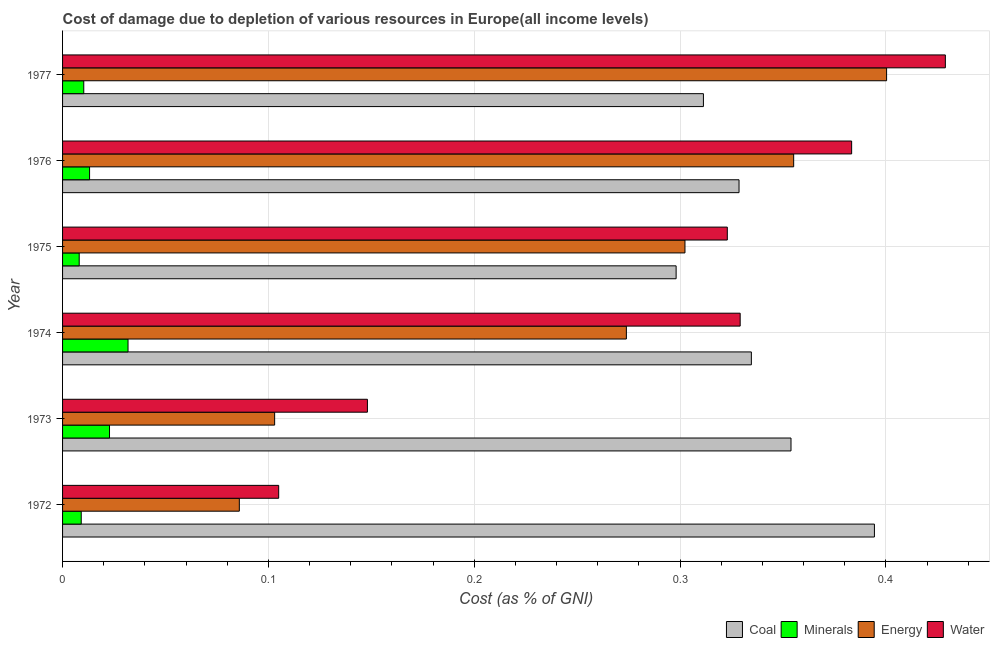How many different coloured bars are there?
Keep it short and to the point. 4. Are the number of bars per tick equal to the number of legend labels?
Provide a succinct answer. Yes. How many bars are there on the 2nd tick from the top?
Provide a succinct answer. 4. What is the label of the 3rd group of bars from the top?
Make the answer very short. 1975. In how many cases, is the number of bars for a given year not equal to the number of legend labels?
Make the answer very short. 0. What is the cost of damage due to depletion of energy in 1977?
Your response must be concise. 0.4. Across all years, what is the maximum cost of damage due to depletion of minerals?
Offer a very short reply. 0.03. Across all years, what is the minimum cost of damage due to depletion of minerals?
Offer a terse response. 0.01. In which year was the cost of damage due to depletion of coal minimum?
Offer a terse response. 1975. What is the total cost of damage due to depletion of coal in the graph?
Ensure brevity in your answer.  2.02. What is the difference between the cost of damage due to depletion of minerals in 1972 and that in 1973?
Provide a succinct answer. -0.01. What is the difference between the cost of damage due to depletion of water in 1972 and the cost of damage due to depletion of minerals in 1974?
Offer a very short reply. 0.07. What is the average cost of damage due to depletion of minerals per year?
Provide a short and direct response. 0.02. In the year 1976, what is the difference between the cost of damage due to depletion of coal and cost of damage due to depletion of water?
Make the answer very short. -0.06. What is the ratio of the cost of damage due to depletion of energy in 1972 to that in 1976?
Provide a short and direct response. 0.24. Is the cost of damage due to depletion of water in 1974 less than that in 1976?
Offer a terse response. Yes. Is the difference between the cost of damage due to depletion of coal in 1975 and 1976 greater than the difference between the cost of damage due to depletion of water in 1975 and 1976?
Provide a short and direct response. Yes. What is the difference between the highest and the second highest cost of damage due to depletion of water?
Give a very brief answer. 0.05. What is the difference between the highest and the lowest cost of damage due to depletion of coal?
Your response must be concise. 0.1. Is it the case that in every year, the sum of the cost of damage due to depletion of coal and cost of damage due to depletion of minerals is greater than the sum of cost of damage due to depletion of water and cost of damage due to depletion of energy?
Ensure brevity in your answer.  No. What does the 2nd bar from the top in 1972 represents?
Offer a terse response. Energy. What does the 4th bar from the bottom in 1975 represents?
Your response must be concise. Water. Are all the bars in the graph horizontal?
Give a very brief answer. Yes. Does the graph contain grids?
Give a very brief answer. Yes. How many legend labels are there?
Your answer should be very brief. 4. What is the title of the graph?
Your answer should be compact. Cost of damage due to depletion of various resources in Europe(all income levels) . What is the label or title of the X-axis?
Give a very brief answer. Cost (as % of GNI). What is the Cost (as % of GNI) in Coal in 1972?
Ensure brevity in your answer.  0.39. What is the Cost (as % of GNI) of Minerals in 1972?
Keep it short and to the point. 0.01. What is the Cost (as % of GNI) of Energy in 1972?
Ensure brevity in your answer.  0.09. What is the Cost (as % of GNI) of Water in 1972?
Give a very brief answer. 0.1. What is the Cost (as % of GNI) in Coal in 1973?
Your answer should be very brief. 0.35. What is the Cost (as % of GNI) in Minerals in 1973?
Give a very brief answer. 0.02. What is the Cost (as % of GNI) of Energy in 1973?
Your answer should be compact. 0.1. What is the Cost (as % of GNI) in Water in 1973?
Make the answer very short. 0.15. What is the Cost (as % of GNI) in Coal in 1974?
Make the answer very short. 0.33. What is the Cost (as % of GNI) of Minerals in 1974?
Provide a succinct answer. 0.03. What is the Cost (as % of GNI) of Energy in 1974?
Offer a very short reply. 0.27. What is the Cost (as % of GNI) of Water in 1974?
Keep it short and to the point. 0.33. What is the Cost (as % of GNI) of Coal in 1975?
Provide a short and direct response. 0.3. What is the Cost (as % of GNI) in Minerals in 1975?
Offer a terse response. 0.01. What is the Cost (as % of GNI) in Energy in 1975?
Give a very brief answer. 0.3. What is the Cost (as % of GNI) of Water in 1975?
Offer a terse response. 0.32. What is the Cost (as % of GNI) in Coal in 1976?
Make the answer very short. 0.33. What is the Cost (as % of GNI) of Minerals in 1976?
Provide a short and direct response. 0.01. What is the Cost (as % of GNI) of Energy in 1976?
Provide a short and direct response. 0.36. What is the Cost (as % of GNI) of Water in 1976?
Offer a very short reply. 0.38. What is the Cost (as % of GNI) in Coal in 1977?
Offer a very short reply. 0.31. What is the Cost (as % of GNI) of Minerals in 1977?
Offer a very short reply. 0.01. What is the Cost (as % of GNI) of Energy in 1977?
Provide a succinct answer. 0.4. What is the Cost (as % of GNI) of Water in 1977?
Make the answer very short. 0.43. Across all years, what is the maximum Cost (as % of GNI) of Coal?
Your answer should be very brief. 0.39. Across all years, what is the maximum Cost (as % of GNI) in Minerals?
Your answer should be compact. 0.03. Across all years, what is the maximum Cost (as % of GNI) in Energy?
Give a very brief answer. 0.4. Across all years, what is the maximum Cost (as % of GNI) of Water?
Offer a very short reply. 0.43. Across all years, what is the minimum Cost (as % of GNI) of Coal?
Ensure brevity in your answer.  0.3. Across all years, what is the minimum Cost (as % of GNI) in Minerals?
Keep it short and to the point. 0.01. Across all years, what is the minimum Cost (as % of GNI) in Energy?
Ensure brevity in your answer.  0.09. Across all years, what is the minimum Cost (as % of GNI) in Water?
Offer a very short reply. 0.1. What is the total Cost (as % of GNI) in Coal in the graph?
Your answer should be very brief. 2.02. What is the total Cost (as % of GNI) of Minerals in the graph?
Give a very brief answer. 0.1. What is the total Cost (as % of GNI) of Energy in the graph?
Keep it short and to the point. 1.52. What is the total Cost (as % of GNI) in Water in the graph?
Offer a very short reply. 1.72. What is the difference between the Cost (as % of GNI) in Coal in 1972 and that in 1973?
Make the answer very short. 0.04. What is the difference between the Cost (as % of GNI) in Minerals in 1972 and that in 1973?
Provide a succinct answer. -0.01. What is the difference between the Cost (as % of GNI) of Energy in 1972 and that in 1973?
Your response must be concise. -0.02. What is the difference between the Cost (as % of GNI) in Water in 1972 and that in 1973?
Provide a short and direct response. -0.04. What is the difference between the Cost (as % of GNI) of Coal in 1972 and that in 1974?
Your response must be concise. 0.06. What is the difference between the Cost (as % of GNI) in Minerals in 1972 and that in 1974?
Give a very brief answer. -0.02. What is the difference between the Cost (as % of GNI) in Energy in 1972 and that in 1974?
Offer a very short reply. -0.19. What is the difference between the Cost (as % of GNI) in Water in 1972 and that in 1974?
Keep it short and to the point. -0.22. What is the difference between the Cost (as % of GNI) in Coal in 1972 and that in 1975?
Provide a short and direct response. 0.1. What is the difference between the Cost (as % of GNI) in Minerals in 1972 and that in 1975?
Give a very brief answer. 0. What is the difference between the Cost (as % of GNI) of Energy in 1972 and that in 1975?
Give a very brief answer. -0.22. What is the difference between the Cost (as % of GNI) of Water in 1972 and that in 1975?
Your response must be concise. -0.22. What is the difference between the Cost (as % of GNI) of Coal in 1972 and that in 1976?
Make the answer very short. 0.07. What is the difference between the Cost (as % of GNI) in Minerals in 1972 and that in 1976?
Your answer should be very brief. -0. What is the difference between the Cost (as % of GNI) of Energy in 1972 and that in 1976?
Provide a short and direct response. -0.27. What is the difference between the Cost (as % of GNI) of Water in 1972 and that in 1976?
Your answer should be compact. -0.28. What is the difference between the Cost (as % of GNI) of Coal in 1972 and that in 1977?
Your response must be concise. 0.08. What is the difference between the Cost (as % of GNI) in Minerals in 1972 and that in 1977?
Offer a terse response. -0. What is the difference between the Cost (as % of GNI) in Energy in 1972 and that in 1977?
Keep it short and to the point. -0.31. What is the difference between the Cost (as % of GNI) in Water in 1972 and that in 1977?
Make the answer very short. -0.32. What is the difference between the Cost (as % of GNI) in Coal in 1973 and that in 1974?
Make the answer very short. 0.02. What is the difference between the Cost (as % of GNI) in Minerals in 1973 and that in 1974?
Offer a terse response. -0.01. What is the difference between the Cost (as % of GNI) of Energy in 1973 and that in 1974?
Keep it short and to the point. -0.17. What is the difference between the Cost (as % of GNI) of Water in 1973 and that in 1974?
Provide a short and direct response. -0.18. What is the difference between the Cost (as % of GNI) of Coal in 1973 and that in 1975?
Ensure brevity in your answer.  0.06. What is the difference between the Cost (as % of GNI) of Minerals in 1973 and that in 1975?
Your answer should be very brief. 0.01. What is the difference between the Cost (as % of GNI) of Energy in 1973 and that in 1975?
Your response must be concise. -0.2. What is the difference between the Cost (as % of GNI) in Water in 1973 and that in 1975?
Offer a terse response. -0.17. What is the difference between the Cost (as % of GNI) in Coal in 1973 and that in 1976?
Make the answer very short. 0.03. What is the difference between the Cost (as % of GNI) of Minerals in 1973 and that in 1976?
Offer a very short reply. 0.01. What is the difference between the Cost (as % of GNI) of Energy in 1973 and that in 1976?
Make the answer very short. -0.25. What is the difference between the Cost (as % of GNI) of Water in 1973 and that in 1976?
Ensure brevity in your answer.  -0.24. What is the difference between the Cost (as % of GNI) in Coal in 1973 and that in 1977?
Your response must be concise. 0.04. What is the difference between the Cost (as % of GNI) of Minerals in 1973 and that in 1977?
Your answer should be compact. 0.01. What is the difference between the Cost (as % of GNI) in Energy in 1973 and that in 1977?
Your answer should be compact. -0.3. What is the difference between the Cost (as % of GNI) of Water in 1973 and that in 1977?
Keep it short and to the point. -0.28. What is the difference between the Cost (as % of GNI) of Coal in 1974 and that in 1975?
Provide a short and direct response. 0.04. What is the difference between the Cost (as % of GNI) of Minerals in 1974 and that in 1975?
Give a very brief answer. 0.02. What is the difference between the Cost (as % of GNI) of Energy in 1974 and that in 1975?
Your answer should be compact. -0.03. What is the difference between the Cost (as % of GNI) of Water in 1974 and that in 1975?
Make the answer very short. 0.01. What is the difference between the Cost (as % of GNI) in Coal in 1974 and that in 1976?
Provide a short and direct response. 0.01. What is the difference between the Cost (as % of GNI) in Minerals in 1974 and that in 1976?
Offer a terse response. 0.02. What is the difference between the Cost (as % of GNI) in Energy in 1974 and that in 1976?
Your answer should be very brief. -0.08. What is the difference between the Cost (as % of GNI) of Water in 1974 and that in 1976?
Keep it short and to the point. -0.05. What is the difference between the Cost (as % of GNI) of Coal in 1974 and that in 1977?
Make the answer very short. 0.02. What is the difference between the Cost (as % of GNI) in Minerals in 1974 and that in 1977?
Your response must be concise. 0.02. What is the difference between the Cost (as % of GNI) in Energy in 1974 and that in 1977?
Provide a short and direct response. -0.13. What is the difference between the Cost (as % of GNI) in Water in 1974 and that in 1977?
Provide a short and direct response. -0.1. What is the difference between the Cost (as % of GNI) of Coal in 1975 and that in 1976?
Give a very brief answer. -0.03. What is the difference between the Cost (as % of GNI) in Minerals in 1975 and that in 1976?
Keep it short and to the point. -0.01. What is the difference between the Cost (as % of GNI) in Energy in 1975 and that in 1976?
Give a very brief answer. -0.05. What is the difference between the Cost (as % of GNI) of Water in 1975 and that in 1976?
Ensure brevity in your answer.  -0.06. What is the difference between the Cost (as % of GNI) in Coal in 1975 and that in 1977?
Ensure brevity in your answer.  -0.01. What is the difference between the Cost (as % of GNI) in Minerals in 1975 and that in 1977?
Make the answer very short. -0. What is the difference between the Cost (as % of GNI) in Energy in 1975 and that in 1977?
Offer a very short reply. -0.1. What is the difference between the Cost (as % of GNI) in Water in 1975 and that in 1977?
Provide a succinct answer. -0.11. What is the difference between the Cost (as % of GNI) of Coal in 1976 and that in 1977?
Your answer should be very brief. 0.02. What is the difference between the Cost (as % of GNI) in Minerals in 1976 and that in 1977?
Your answer should be very brief. 0. What is the difference between the Cost (as % of GNI) in Energy in 1976 and that in 1977?
Your answer should be very brief. -0.05. What is the difference between the Cost (as % of GNI) in Water in 1976 and that in 1977?
Provide a succinct answer. -0.05. What is the difference between the Cost (as % of GNI) in Coal in 1972 and the Cost (as % of GNI) in Minerals in 1973?
Your answer should be compact. 0.37. What is the difference between the Cost (as % of GNI) in Coal in 1972 and the Cost (as % of GNI) in Energy in 1973?
Your answer should be very brief. 0.29. What is the difference between the Cost (as % of GNI) in Coal in 1972 and the Cost (as % of GNI) in Water in 1973?
Make the answer very short. 0.25. What is the difference between the Cost (as % of GNI) in Minerals in 1972 and the Cost (as % of GNI) in Energy in 1973?
Provide a succinct answer. -0.09. What is the difference between the Cost (as % of GNI) of Minerals in 1972 and the Cost (as % of GNI) of Water in 1973?
Your response must be concise. -0.14. What is the difference between the Cost (as % of GNI) of Energy in 1972 and the Cost (as % of GNI) of Water in 1973?
Your answer should be compact. -0.06. What is the difference between the Cost (as % of GNI) in Coal in 1972 and the Cost (as % of GNI) in Minerals in 1974?
Your response must be concise. 0.36. What is the difference between the Cost (as % of GNI) of Coal in 1972 and the Cost (as % of GNI) of Energy in 1974?
Your answer should be compact. 0.12. What is the difference between the Cost (as % of GNI) in Coal in 1972 and the Cost (as % of GNI) in Water in 1974?
Ensure brevity in your answer.  0.07. What is the difference between the Cost (as % of GNI) of Minerals in 1972 and the Cost (as % of GNI) of Energy in 1974?
Provide a succinct answer. -0.26. What is the difference between the Cost (as % of GNI) of Minerals in 1972 and the Cost (as % of GNI) of Water in 1974?
Your answer should be compact. -0.32. What is the difference between the Cost (as % of GNI) in Energy in 1972 and the Cost (as % of GNI) in Water in 1974?
Offer a very short reply. -0.24. What is the difference between the Cost (as % of GNI) in Coal in 1972 and the Cost (as % of GNI) in Minerals in 1975?
Offer a terse response. 0.39. What is the difference between the Cost (as % of GNI) of Coal in 1972 and the Cost (as % of GNI) of Energy in 1975?
Make the answer very short. 0.09. What is the difference between the Cost (as % of GNI) in Coal in 1972 and the Cost (as % of GNI) in Water in 1975?
Your answer should be compact. 0.07. What is the difference between the Cost (as % of GNI) of Minerals in 1972 and the Cost (as % of GNI) of Energy in 1975?
Provide a short and direct response. -0.29. What is the difference between the Cost (as % of GNI) of Minerals in 1972 and the Cost (as % of GNI) of Water in 1975?
Ensure brevity in your answer.  -0.31. What is the difference between the Cost (as % of GNI) in Energy in 1972 and the Cost (as % of GNI) in Water in 1975?
Your answer should be compact. -0.24. What is the difference between the Cost (as % of GNI) in Coal in 1972 and the Cost (as % of GNI) in Minerals in 1976?
Your answer should be compact. 0.38. What is the difference between the Cost (as % of GNI) in Coal in 1972 and the Cost (as % of GNI) in Energy in 1976?
Offer a very short reply. 0.04. What is the difference between the Cost (as % of GNI) in Coal in 1972 and the Cost (as % of GNI) in Water in 1976?
Offer a very short reply. 0.01. What is the difference between the Cost (as % of GNI) of Minerals in 1972 and the Cost (as % of GNI) of Energy in 1976?
Give a very brief answer. -0.35. What is the difference between the Cost (as % of GNI) in Minerals in 1972 and the Cost (as % of GNI) in Water in 1976?
Ensure brevity in your answer.  -0.37. What is the difference between the Cost (as % of GNI) of Energy in 1972 and the Cost (as % of GNI) of Water in 1976?
Your answer should be compact. -0.3. What is the difference between the Cost (as % of GNI) of Coal in 1972 and the Cost (as % of GNI) of Minerals in 1977?
Keep it short and to the point. 0.38. What is the difference between the Cost (as % of GNI) in Coal in 1972 and the Cost (as % of GNI) in Energy in 1977?
Your response must be concise. -0.01. What is the difference between the Cost (as % of GNI) of Coal in 1972 and the Cost (as % of GNI) of Water in 1977?
Offer a very short reply. -0.03. What is the difference between the Cost (as % of GNI) in Minerals in 1972 and the Cost (as % of GNI) in Energy in 1977?
Offer a terse response. -0.39. What is the difference between the Cost (as % of GNI) in Minerals in 1972 and the Cost (as % of GNI) in Water in 1977?
Offer a very short reply. -0.42. What is the difference between the Cost (as % of GNI) of Energy in 1972 and the Cost (as % of GNI) of Water in 1977?
Keep it short and to the point. -0.34. What is the difference between the Cost (as % of GNI) in Coal in 1973 and the Cost (as % of GNI) in Minerals in 1974?
Your answer should be compact. 0.32. What is the difference between the Cost (as % of GNI) of Coal in 1973 and the Cost (as % of GNI) of Energy in 1974?
Offer a very short reply. 0.08. What is the difference between the Cost (as % of GNI) in Coal in 1973 and the Cost (as % of GNI) in Water in 1974?
Offer a terse response. 0.02. What is the difference between the Cost (as % of GNI) in Minerals in 1973 and the Cost (as % of GNI) in Energy in 1974?
Offer a terse response. -0.25. What is the difference between the Cost (as % of GNI) in Minerals in 1973 and the Cost (as % of GNI) in Water in 1974?
Your answer should be compact. -0.31. What is the difference between the Cost (as % of GNI) in Energy in 1973 and the Cost (as % of GNI) in Water in 1974?
Make the answer very short. -0.23. What is the difference between the Cost (as % of GNI) in Coal in 1973 and the Cost (as % of GNI) in Minerals in 1975?
Keep it short and to the point. 0.35. What is the difference between the Cost (as % of GNI) of Coal in 1973 and the Cost (as % of GNI) of Energy in 1975?
Your response must be concise. 0.05. What is the difference between the Cost (as % of GNI) of Coal in 1973 and the Cost (as % of GNI) of Water in 1975?
Your answer should be compact. 0.03. What is the difference between the Cost (as % of GNI) in Minerals in 1973 and the Cost (as % of GNI) in Energy in 1975?
Provide a short and direct response. -0.28. What is the difference between the Cost (as % of GNI) of Minerals in 1973 and the Cost (as % of GNI) of Water in 1975?
Offer a very short reply. -0.3. What is the difference between the Cost (as % of GNI) of Energy in 1973 and the Cost (as % of GNI) of Water in 1975?
Your response must be concise. -0.22. What is the difference between the Cost (as % of GNI) in Coal in 1973 and the Cost (as % of GNI) in Minerals in 1976?
Your answer should be compact. 0.34. What is the difference between the Cost (as % of GNI) in Coal in 1973 and the Cost (as % of GNI) in Energy in 1976?
Ensure brevity in your answer.  -0. What is the difference between the Cost (as % of GNI) of Coal in 1973 and the Cost (as % of GNI) of Water in 1976?
Provide a succinct answer. -0.03. What is the difference between the Cost (as % of GNI) of Minerals in 1973 and the Cost (as % of GNI) of Energy in 1976?
Offer a terse response. -0.33. What is the difference between the Cost (as % of GNI) of Minerals in 1973 and the Cost (as % of GNI) of Water in 1976?
Give a very brief answer. -0.36. What is the difference between the Cost (as % of GNI) in Energy in 1973 and the Cost (as % of GNI) in Water in 1976?
Offer a terse response. -0.28. What is the difference between the Cost (as % of GNI) of Coal in 1973 and the Cost (as % of GNI) of Minerals in 1977?
Your answer should be very brief. 0.34. What is the difference between the Cost (as % of GNI) of Coal in 1973 and the Cost (as % of GNI) of Energy in 1977?
Your answer should be compact. -0.05. What is the difference between the Cost (as % of GNI) of Coal in 1973 and the Cost (as % of GNI) of Water in 1977?
Ensure brevity in your answer.  -0.07. What is the difference between the Cost (as % of GNI) of Minerals in 1973 and the Cost (as % of GNI) of Energy in 1977?
Provide a succinct answer. -0.38. What is the difference between the Cost (as % of GNI) in Minerals in 1973 and the Cost (as % of GNI) in Water in 1977?
Keep it short and to the point. -0.41. What is the difference between the Cost (as % of GNI) of Energy in 1973 and the Cost (as % of GNI) of Water in 1977?
Make the answer very short. -0.33. What is the difference between the Cost (as % of GNI) in Coal in 1974 and the Cost (as % of GNI) in Minerals in 1975?
Your answer should be very brief. 0.33. What is the difference between the Cost (as % of GNI) in Coal in 1974 and the Cost (as % of GNI) in Energy in 1975?
Keep it short and to the point. 0.03. What is the difference between the Cost (as % of GNI) in Coal in 1974 and the Cost (as % of GNI) in Water in 1975?
Offer a terse response. 0.01. What is the difference between the Cost (as % of GNI) of Minerals in 1974 and the Cost (as % of GNI) of Energy in 1975?
Your answer should be very brief. -0.27. What is the difference between the Cost (as % of GNI) of Minerals in 1974 and the Cost (as % of GNI) of Water in 1975?
Your answer should be very brief. -0.29. What is the difference between the Cost (as % of GNI) in Energy in 1974 and the Cost (as % of GNI) in Water in 1975?
Provide a short and direct response. -0.05. What is the difference between the Cost (as % of GNI) in Coal in 1974 and the Cost (as % of GNI) in Minerals in 1976?
Your answer should be very brief. 0.32. What is the difference between the Cost (as % of GNI) of Coal in 1974 and the Cost (as % of GNI) of Energy in 1976?
Your response must be concise. -0.02. What is the difference between the Cost (as % of GNI) of Coal in 1974 and the Cost (as % of GNI) of Water in 1976?
Give a very brief answer. -0.05. What is the difference between the Cost (as % of GNI) in Minerals in 1974 and the Cost (as % of GNI) in Energy in 1976?
Make the answer very short. -0.32. What is the difference between the Cost (as % of GNI) of Minerals in 1974 and the Cost (as % of GNI) of Water in 1976?
Your answer should be very brief. -0.35. What is the difference between the Cost (as % of GNI) of Energy in 1974 and the Cost (as % of GNI) of Water in 1976?
Give a very brief answer. -0.11. What is the difference between the Cost (as % of GNI) of Coal in 1974 and the Cost (as % of GNI) of Minerals in 1977?
Your answer should be compact. 0.32. What is the difference between the Cost (as % of GNI) of Coal in 1974 and the Cost (as % of GNI) of Energy in 1977?
Provide a short and direct response. -0.07. What is the difference between the Cost (as % of GNI) of Coal in 1974 and the Cost (as % of GNI) of Water in 1977?
Provide a short and direct response. -0.09. What is the difference between the Cost (as % of GNI) in Minerals in 1974 and the Cost (as % of GNI) in Energy in 1977?
Offer a very short reply. -0.37. What is the difference between the Cost (as % of GNI) of Minerals in 1974 and the Cost (as % of GNI) of Water in 1977?
Ensure brevity in your answer.  -0.4. What is the difference between the Cost (as % of GNI) in Energy in 1974 and the Cost (as % of GNI) in Water in 1977?
Make the answer very short. -0.15. What is the difference between the Cost (as % of GNI) in Coal in 1975 and the Cost (as % of GNI) in Minerals in 1976?
Your answer should be very brief. 0.28. What is the difference between the Cost (as % of GNI) in Coal in 1975 and the Cost (as % of GNI) in Energy in 1976?
Your answer should be compact. -0.06. What is the difference between the Cost (as % of GNI) of Coal in 1975 and the Cost (as % of GNI) of Water in 1976?
Provide a short and direct response. -0.09. What is the difference between the Cost (as % of GNI) in Minerals in 1975 and the Cost (as % of GNI) in Energy in 1976?
Offer a very short reply. -0.35. What is the difference between the Cost (as % of GNI) in Minerals in 1975 and the Cost (as % of GNI) in Water in 1976?
Your answer should be compact. -0.38. What is the difference between the Cost (as % of GNI) in Energy in 1975 and the Cost (as % of GNI) in Water in 1976?
Make the answer very short. -0.08. What is the difference between the Cost (as % of GNI) in Coal in 1975 and the Cost (as % of GNI) in Minerals in 1977?
Your answer should be compact. 0.29. What is the difference between the Cost (as % of GNI) of Coal in 1975 and the Cost (as % of GNI) of Energy in 1977?
Offer a very short reply. -0.1. What is the difference between the Cost (as % of GNI) in Coal in 1975 and the Cost (as % of GNI) in Water in 1977?
Your response must be concise. -0.13. What is the difference between the Cost (as % of GNI) of Minerals in 1975 and the Cost (as % of GNI) of Energy in 1977?
Ensure brevity in your answer.  -0.39. What is the difference between the Cost (as % of GNI) in Minerals in 1975 and the Cost (as % of GNI) in Water in 1977?
Give a very brief answer. -0.42. What is the difference between the Cost (as % of GNI) of Energy in 1975 and the Cost (as % of GNI) of Water in 1977?
Make the answer very short. -0.13. What is the difference between the Cost (as % of GNI) of Coal in 1976 and the Cost (as % of GNI) of Minerals in 1977?
Ensure brevity in your answer.  0.32. What is the difference between the Cost (as % of GNI) of Coal in 1976 and the Cost (as % of GNI) of Energy in 1977?
Keep it short and to the point. -0.07. What is the difference between the Cost (as % of GNI) in Coal in 1976 and the Cost (as % of GNI) in Water in 1977?
Make the answer very short. -0.1. What is the difference between the Cost (as % of GNI) in Minerals in 1976 and the Cost (as % of GNI) in Energy in 1977?
Offer a very short reply. -0.39. What is the difference between the Cost (as % of GNI) of Minerals in 1976 and the Cost (as % of GNI) of Water in 1977?
Offer a very short reply. -0.42. What is the difference between the Cost (as % of GNI) of Energy in 1976 and the Cost (as % of GNI) of Water in 1977?
Provide a short and direct response. -0.07. What is the average Cost (as % of GNI) in Coal per year?
Give a very brief answer. 0.34. What is the average Cost (as % of GNI) of Minerals per year?
Offer a very short reply. 0.02. What is the average Cost (as % of GNI) in Energy per year?
Your answer should be compact. 0.25. What is the average Cost (as % of GNI) in Water per year?
Give a very brief answer. 0.29. In the year 1972, what is the difference between the Cost (as % of GNI) in Coal and Cost (as % of GNI) in Minerals?
Your answer should be very brief. 0.39. In the year 1972, what is the difference between the Cost (as % of GNI) of Coal and Cost (as % of GNI) of Energy?
Make the answer very short. 0.31. In the year 1972, what is the difference between the Cost (as % of GNI) of Coal and Cost (as % of GNI) of Water?
Provide a short and direct response. 0.29. In the year 1972, what is the difference between the Cost (as % of GNI) in Minerals and Cost (as % of GNI) in Energy?
Give a very brief answer. -0.08. In the year 1972, what is the difference between the Cost (as % of GNI) in Minerals and Cost (as % of GNI) in Water?
Your response must be concise. -0.1. In the year 1972, what is the difference between the Cost (as % of GNI) in Energy and Cost (as % of GNI) in Water?
Give a very brief answer. -0.02. In the year 1973, what is the difference between the Cost (as % of GNI) in Coal and Cost (as % of GNI) in Minerals?
Make the answer very short. 0.33. In the year 1973, what is the difference between the Cost (as % of GNI) of Coal and Cost (as % of GNI) of Energy?
Your response must be concise. 0.25. In the year 1973, what is the difference between the Cost (as % of GNI) in Coal and Cost (as % of GNI) in Water?
Give a very brief answer. 0.21. In the year 1973, what is the difference between the Cost (as % of GNI) of Minerals and Cost (as % of GNI) of Energy?
Provide a succinct answer. -0.08. In the year 1973, what is the difference between the Cost (as % of GNI) of Minerals and Cost (as % of GNI) of Water?
Keep it short and to the point. -0.13. In the year 1973, what is the difference between the Cost (as % of GNI) of Energy and Cost (as % of GNI) of Water?
Offer a very short reply. -0.05. In the year 1974, what is the difference between the Cost (as % of GNI) of Coal and Cost (as % of GNI) of Minerals?
Your answer should be compact. 0.3. In the year 1974, what is the difference between the Cost (as % of GNI) in Coal and Cost (as % of GNI) in Energy?
Your response must be concise. 0.06. In the year 1974, what is the difference between the Cost (as % of GNI) of Coal and Cost (as % of GNI) of Water?
Make the answer very short. 0.01. In the year 1974, what is the difference between the Cost (as % of GNI) of Minerals and Cost (as % of GNI) of Energy?
Offer a terse response. -0.24. In the year 1974, what is the difference between the Cost (as % of GNI) in Minerals and Cost (as % of GNI) in Water?
Your answer should be compact. -0.3. In the year 1974, what is the difference between the Cost (as % of GNI) of Energy and Cost (as % of GNI) of Water?
Offer a terse response. -0.06. In the year 1975, what is the difference between the Cost (as % of GNI) of Coal and Cost (as % of GNI) of Minerals?
Offer a terse response. 0.29. In the year 1975, what is the difference between the Cost (as % of GNI) in Coal and Cost (as % of GNI) in Energy?
Ensure brevity in your answer.  -0. In the year 1975, what is the difference between the Cost (as % of GNI) of Coal and Cost (as % of GNI) of Water?
Keep it short and to the point. -0.02. In the year 1975, what is the difference between the Cost (as % of GNI) of Minerals and Cost (as % of GNI) of Energy?
Your response must be concise. -0.29. In the year 1975, what is the difference between the Cost (as % of GNI) in Minerals and Cost (as % of GNI) in Water?
Provide a succinct answer. -0.31. In the year 1975, what is the difference between the Cost (as % of GNI) of Energy and Cost (as % of GNI) of Water?
Offer a terse response. -0.02. In the year 1976, what is the difference between the Cost (as % of GNI) of Coal and Cost (as % of GNI) of Minerals?
Your answer should be compact. 0.32. In the year 1976, what is the difference between the Cost (as % of GNI) of Coal and Cost (as % of GNI) of Energy?
Provide a succinct answer. -0.03. In the year 1976, what is the difference between the Cost (as % of GNI) in Coal and Cost (as % of GNI) in Water?
Provide a succinct answer. -0.05. In the year 1976, what is the difference between the Cost (as % of GNI) of Minerals and Cost (as % of GNI) of Energy?
Keep it short and to the point. -0.34. In the year 1976, what is the difference between the Cost (as % of GNI) in Minerals and Cost (as % of GNI) in Water?
Provide a succinct answer. -0.37. In the year 1976, what is the difference between the Cost (as % of GNI) in Energy and Cost (as % of GNI) in Water?
Keep it short and to the point. -0.03. In the year 1977, what is the difference between the Cost (as % of GNI) of Coal and Cost (as % of GNI) of Minerals?
Your answer should be very brief. 0.3. In the year 1977, what is the difference between the Cost (as % of GNI) of Coal and Cost (as % of GNI) of Energy?
Keep it short and to the point. -0.09. In the year 1977, what is the difference between the Cost (as % of GNI) of Coal and Cost (as % of GNI) of Water?
Provide a short and direct response. -0.12. In the year 1977, what is the difference between the Cost (as % of GNI) of Minerals and Cost (as % of GNI) of Energy?
Keep it short and to the point. -0.39. In the year 1977, what is the difference between the Cost (as % of GNI) of Minerals and Cost (as % of GNI) of Water?
Provide a succinct answer. -0.42. In the year 1977, what is the difference between the Cost (as % of GNI) in Energy and Cost (as % of GNI) in Water?
Your answer should be very brief. -0.03. What is the ratio of the Cost (as % of GNI) in Coal in 1972 to that in 1973?
Your answer should be compact. 1.11. What is the ratio of the Cost (as % of GNI) in Minerals in 1972 to that in 1973?
Ensure brevity in your answer.  0.4. What is the ratio of the Cost (as % of GNI) in Energy in 1972 to that in 1973?
Make the answer very short. 0.83. What is the ratio of the Cost (as % of GNI) in Water in 1972 to that in 1973?
Ensure brevity in your answer.  0.71. What is the ratio of the Cost (as % of GNI) of Coal in 1972 to that in 1974?
Your response must be concise. 1.18. What is the ratio of the Cost (as % of GNI) of Minerals in 1972 to that in 1974?
Keep it short and to the point. 0.29. What is the ratio of the Cost (as % of GNI) in Energy in 1972 to that in 1974?
Your answer should be compact. 0.31. What is the ratio of the Cost (as % of GNI) of Water in 1972 to that in 1974?
Offer a very short reply. 0.32. What is the ratio of the Cost (as % of GNI) of Coal in 1972 to that in 1975?
Offer a very short reply. 1.32. What is the ratio of the Cost (as % of GNI) in Minerals in 1972 to that in 1975?
Keep it short and to the point. 1.12. What is the ratio of the Cost (as % of GNI) in Energy in 1972 to that in 1975?
Provide a short and direct response. 0.28. What is the ratio of the Cost (as % of GNI) of Water in 1972 to that in 1975?
Your response must be concise. 0.33. What is the ratio of the Cost (as % of GNI) of Coal in 1972 to that in 1976?
Provide a short and direct response. 1.2. What is the ratio of the Cost (as % of GNI) in Minerals in 1972 to that in 1976?
Keep it short and to the point. 0.69. What is the ratio of the Cost (as % of GNI) of Energy in 1972 to that in 1976?
Your response must be concise. 0.24. What is the ratio of the Cost (as % of GNI) of Water in 1972 to that in 1976?
Provide a short and direct response. 0.27. What is the ratio of the Cost (as % of GNI) of Coal in 1972 to that in 1977?
Provide a succinct answer. 1.27. What is the ratio of the Cost (as % of GNI) of Minerals in 1972 to that in 1977?
Make the answer very short. 0.88. What is the ratio of the Cost (as % of GNI) of Energy in 1972 to that in 1977?
Provide a succinct answer. 0.21. What is the ratio of the Cost (as % of GNI) of Water in 1972 to that in 1977?
Provide a succinct answer. 0.24. What is the ratio of the Cost (as % of GNI) of Coal in 1973 to that in 1974?
Provide a short and direct response. 1.06. What is the ratio of the Cost (as % of GNI) in Minerals in 1973 to that in 1974?
Your response must be concise. 0.72. What is the ratio of the Cost (as % of GNI) of Energy in 1973 to that in 1974?
Make the answer very short. 0.38. What is the ratio of the Cost (as % of GNI) of Water in 1973 to that in 1974?
Ensure brevity in your answer.  0.45. What is the ratio of the Cost (as % of GNI) of Coal in 1973 to that in 1975?
Offer a very short reply. 1.19. What is the ratio of the Cost (as % of GNI) of Minerals in 1973 to that in 1975?
Your response must be concise. 2.82. What is the ratio of the Cost (as % of GNI) of Energy in 1973 to that in 1975?
Offer a terse response. 0.34. What is the ratio of the Cost (as % of GNI) in Water in 1973 to that in 1975?
Offer a terse response. 0.46. What is the ratio of the Cost (as % of GNI) of Coal in 1973 to that in 1976?
Give a very brief answer. 1.08. What is the ratio of the Cost (as % of GNI) of Minerals in 1973 to that in 1976?
Keep it short and to the point. 1.74. What is the ratio of the Cost (as % of GNI) in Energy in 1973 to that in 1976?
Provide a short and direct response. 0.29. What is the ratio of the Cost (as % of GNI) of Water in 1973 to that in 1976?
Ensure brevity in your answer.  0.39. What is the ratio of the Cost (as % of GNI) in Coal in 1973 to that in 1977?
Offer a terse response. 1.14. What is the ratio of the Cost (as % of GNI) of Minerals in 1973 to that in 1977?
Keep it short and to the point. 2.21. What is the ratio of the Cost (as % of GNI) of Energy in 1973 to that in 1977?
Provide a succinct answer. 0.26. What is the ratio of the Cost (as % of GNI) of Water in 1973 to that in 1977?
Provide a short and direct response. 0.35. What is the ratio of the Cost (as % of GNI) in Coal in 1974 to that in 1975?
Keep it short and to the point. 1.12. What is the ratio of the Cost (as % of GNI) in Minerals in 1974 to that in 1975?
Make the answer very short. 3.93. What is the ratio of the Cost (as % of GNI) of Energy in 1974 to that in 1975?
Give a very brief answer. 0.91. What is the ratio of the Cost (as % of GNI) in Water in 1974 to that in 1975?
Your answer should be very brief. 1.02. What is the ratio of the Cost (as % of GNI) in Coal in 1974 to that in 1976?
Provide a succinct answer. 1.02. What is the ratio of the Cost (as % of GNI) of Minerals in 1974 to that in 1976?
Your answer should be compact. 2.42. What is the ratio of the Cost (as % of GNI) of Energy in 1974 to that in 1976?
Your response must be concise. 0.77. What is the ratio of the Cost (as % of GNI) in Water in 1974 to that in 1976?
Your answer should be compact. 0.86. What is the ratio of the Cost (as % of GNI) in Coal in 1974 to that in 1977?
Your answer should be compact. 1.07. What is the ratio of the Cost (as % of GNI) in Minerals in 1974 to that in 1977?
Offer a terse response. 3.09. What is the ratio of the Cost (as % of GNI) in Energy in 1974 to that in 1977?
Keep it short and to the point. 0.68. What is the ratio of the Cost (as % of GNI) in Water in 1974 to that in 1977?
Make the answer very short. 0.77. What is the ratio of the Cost (as % of GNI) in Coal in 1975 to that in 1976?
Ensure brevity in your answer.  0.91. What is the ratio of the Cost (as % of GNI) in Minerals in 1975 to that in 1976?
Ensure brevity in your answer.  0.62. What is the ratio of the Cost (as % of GNI) of Energy in 1975 to that in 1976?
Offer a very short reply. 0.85. What is the ratio of the Cost (as % of GNI) of Water in 1975 to that in 1976?
Keep it short and to the point. 0.84. What is the ratio of the Cost (as % of GNI) of Coal in 1975 to that in 1977?
Offer a very short reply. 0.96. What is the ratio of the Cost (as % of GNI) of Minerals in 1975 to that in 1977?
Provide a succinct answer. 0.78. What is the ratio of the Cost (as % of GNI) of Energy in 1975 to that in 1977?
Your answer should be very brief. 0.76. What is the ratio of the Cost (as % of GNI) of Water in 1975 to that in 1977?
Your answer should be compact. 0.75. What is the ratio of the Cost (as % of GNI) of Coal in 1976 to that in 1977?
Your answer should be compact. 1.06. What is the ratio of the Cost (as % of GNI) in Minerals in 1976 to that in 1977?
Offer a very short reply. 1.27. What is the ratio of the Cost (as % of GNI) in Energy in 1976 to that in 1977?
Provide a succinct answer. 0.89. What is the ratio of the Cost (as % of GNI) of Water in 1976 to that in 1977?
Your response must be concise. 0.89. What is the difference between the highest and the second highest Cost (as % of GNI) of Coal?
Ensure brevity in your answer.  0.04. What is the difference between the highest and the second highest Cost (as % of GNI) of Minerals?
Offer a very short reply. 0.01. What is the difference between the highest and the second highest Cost (as % of GNI) of Energy?
Your answer should be compact. 0.05. What is the difference between the highest and the second highest Cost (as % of GNI) in Water?
Give a very brief answer. 0.05. What is the difference between the highest and the lowest Cost (as % of GNI) in Coal?
Keep it short and to the point. 0.1. What is the difference between the highest and the lowest Cost (as % of GNI) in Minerals?
Your answer should be very brief. 0.02. What is the difference between the highest and the lowest Cost (as % of GNI) in Energy?
Your response must be concise. 0.31. What is the difference between the highest and the lowest Cost (as % of GNI) of Water?
Give a very brief answer. 0.32. 